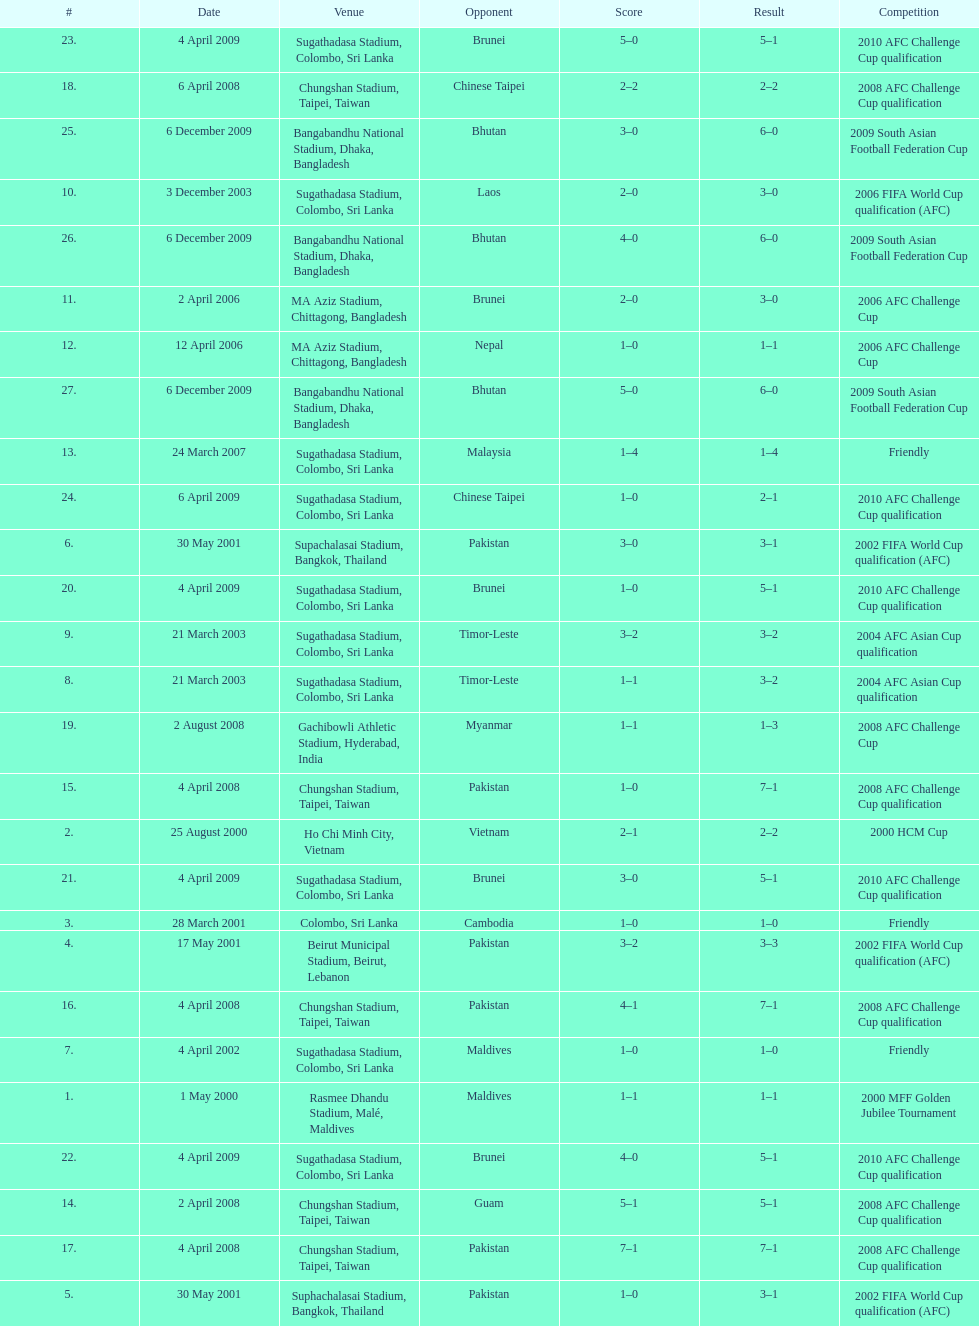What was the total number of goals score in the sri lanka - malaysia game of march 24, 2007? 5. 